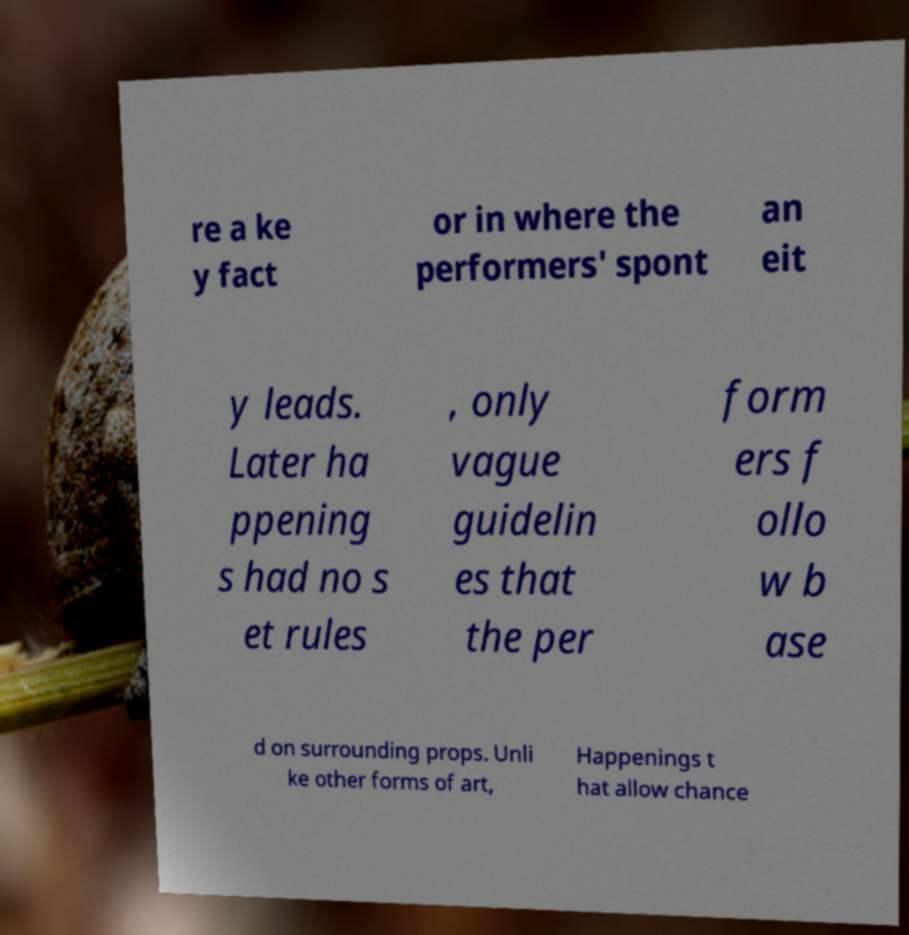Can you accurately transcribe the text from the provided image for me? re a ke y fact or in where the performers' spont an eit y leads. Later ha ppening s had no s et rules , only vague guidelin es that the per form ers f ollo w b ase d on surrounding props. Unli ke other forms of art, Happenings t hat allow chance 